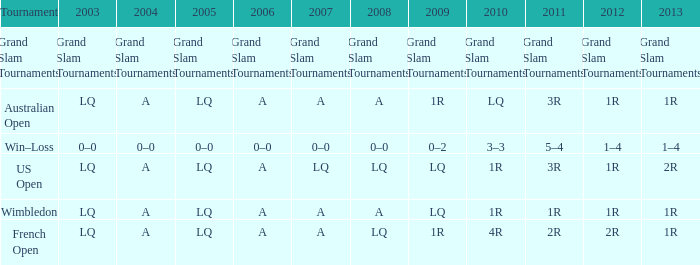Which tournament has a 2013 of 1r, and a 2012 of 1r? Australian Open, Wimbledon. 